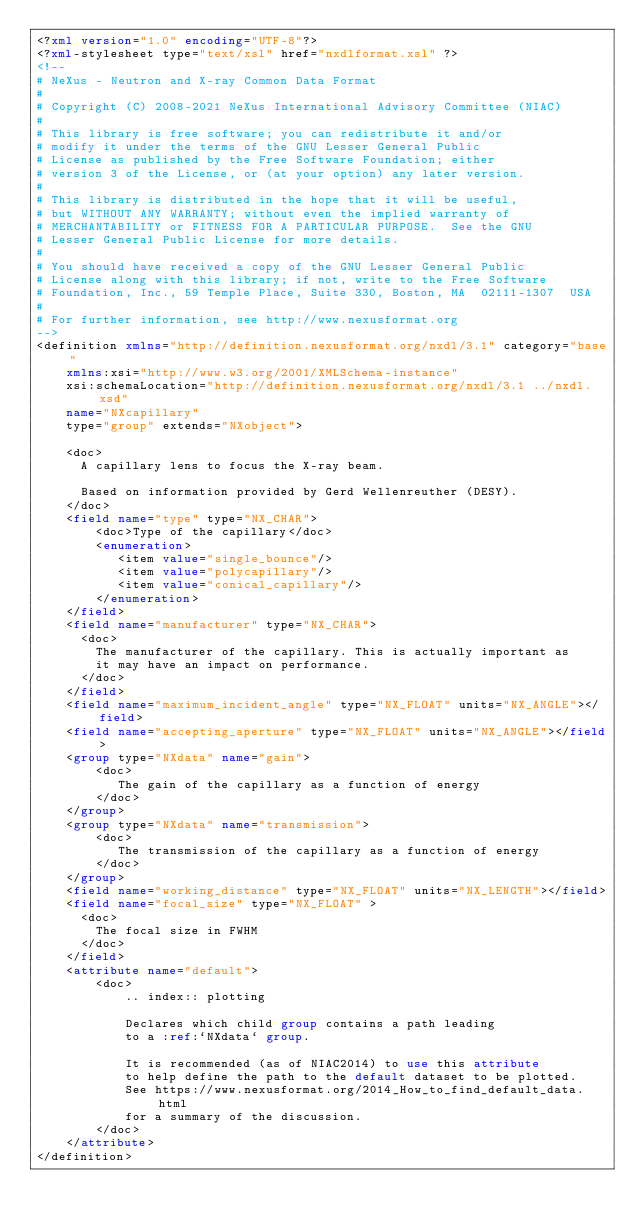Convert code to text. <code><loc_0><loc_0><loc_500><loc_500><_XML_><?xml version="1.0" encoding="UTF-8"?>
<?xml-stylesheet type="text/xsl" href="nxdlformat.xsl" ?>
<!--
# NeXus - Neutron and X-ray Common Data Format
# 
# Copyright (C) 2008-2021 NeXus International Advisory Committee (NIAC)
# 
# This library is free software; you can redistribute it and/or
# modify it under the terms of the GNU Lesser General Public
# License as published by the Free Software Foundation; either
# version 3 of the License, or (at your option) any later version.
#
# This library is distributed in the hope that it will be useful,
# but WITHOUT ANY WARRANTY; without even the implied warranty of
# MERCHANTABILITY or FITNESS FOR A PARTICULAR PURPOSE.  See the GNU
# Lesser General Public License for more details.
#
# You should have received a copy of the GNU Lesser General Public
# License along with this library; if not, write to the Free Software
# Foundation, Inc., 59 Temple Place, Suite 330, Boston, MA  02111-1307  USA
#
# For further information, see http://www.nexusformat.org
-->
<definition xmlns="http://definition.nexusformat.org/nxdl/3.1" category="base"
    xmlns:xsi="http://www.w3.org/2001/XMLSchema-instance"
    xsi:schemaLocation="http://definition.nexusformat.org/nxdl/3.1 ../nxdl.xsd"
    name="NXcapillary"
    type="group" extends="NXobject">

    <doc>
      A capillary lens to focus the X-ray beam.
      
      Based on information provided by Gerd Wellenreuther (DESY).
    </doc>
    <field name="type" type="NX_CHAR">
        <doc>Type of the capillary</doc>
        <enumeration>
           <item value="single_bounce"/>
           <item value="polycapillary"/>
           <item value="conical_capillary"/>
        </enumeration>
    </field>
    <field name="manufacturer" type="NX_CHAR">
      <doc>
        The manufacturer of the capillary. This is actually important as 
        it may have an impact on performance.
      </doc>
    </field>
    <field name="maximum_incident_angle" type="NX_FLOAT" units="NX_ANGLE"></field>
    <field name="accepting_aperture" type="NX_FLOAT" units="NX_ANGLE"></field>
    <group type="NXdata" name="gain">
        <doc>
           The gain of the capillary as a function of energy
        </doc>
    </group>
    <group type="NXdata" name="transmission">
        <doc>
           The transmission of the capillary as a function of energy
        </doc>
    </group>
    <field name="working_distance" type="NX_FLOAT" units="NX_LENGTH"></field>
    <field name="focal_size" type="NX_FLOAT" >
      <doc>
        The focal size in FWHM
      </doc>
    </field>
    <attribute name="default">
        <doc>
            .. index:: plotting
            
            Declares which child group contains a path leading 
            to a :ref:`NXdata` group.
            
            It is recommended (as of NIAC2014) to use this attribute
            to help define the path to the default dataset to be plotted.
            See https://www.nexusformat.org/2014_How_to_find_default_data.html
            for a summary of the discussion.
        </doc>
    </attribute>
</definition>
</code> 